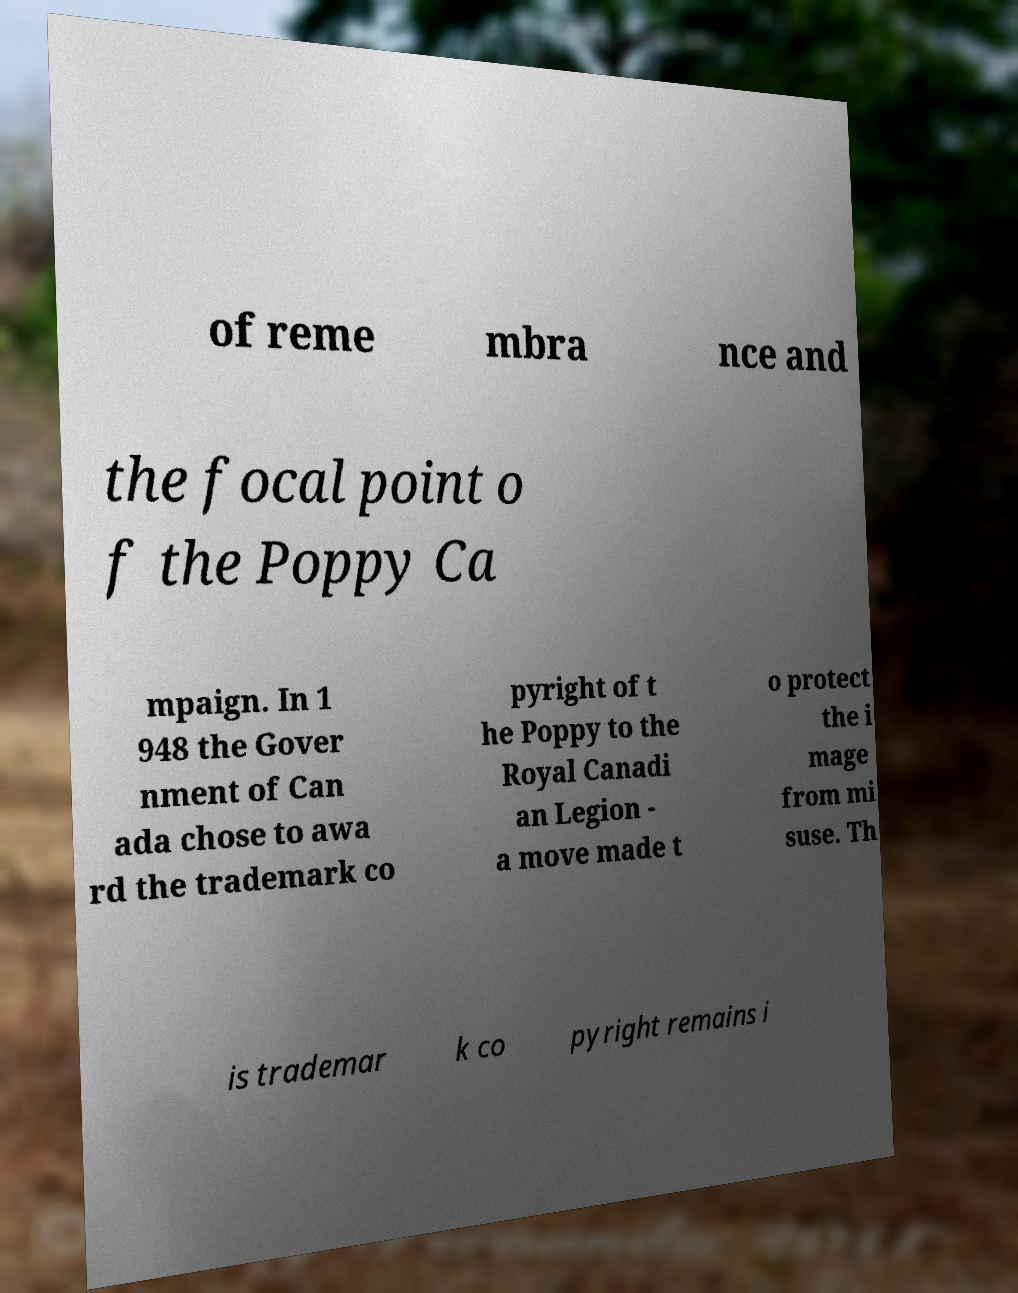There's text embedded in this image that I need extracted. Can you transcribe it verbatim? of reme mbra nce and the focal point o f the Poppy Ca mpaign. In 1 948 the Gover nment of Can ada chose to awa rd the trademark co pyright of t he Poppy to the Royal Canadi an Legion - a move made t o protect the i mage from mi suse. Th is trademar k co pyright remains i 